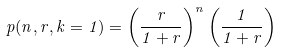<formula> <loc_0><loc_0><loc_500><loc_500>p ( n , r , k = 1 ) = \left ( \frac { r } { 1 + r } \right ) ^ { n } \left ( \frac { 1 } { 1 + r } \right )</formula> 